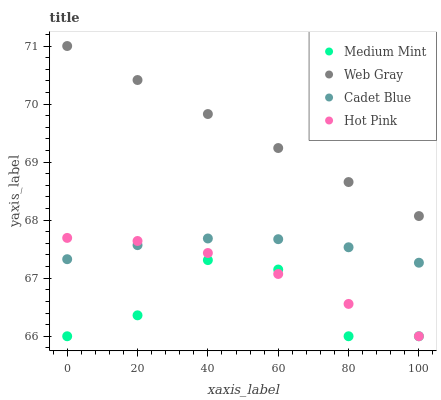Does Medium Mint have the minimum area under the curve?
Answer yes or no. Yes. Does Web Gray have the maximum area under the curve?
Answer yes or no. Yes. Does Cadet Blue have the minimum area under the curve?
Answer yes or no. No. Does Cadet Blue have the maximum area under the curve?
Answer yes or no. No. Is Web Gray the smoothest?
Answer yes or no. Yes. Is Medium Mint the roughest?
Answer yes or no. Yes. Is Cadet Blue the smoothest?
Answer yes or no. No. Is Cadet Blue the roughest?
Answer yes or no. No. Does Medium Mint have the lowest value?
Answer yes or no. Yes. Does Cadet Blue have the lowest value?
Answer yes or no. No. Does Web Gray have the highest value?
Answer yes or no. Yes. Does Cadet Blue have the highest value?
Answer yes or no. No. Is Medium Mint less than Cadet Blue?
Answer yes or no. Yes. Is Web Gray greater than Cadet Blue?
Answer yes or no. Yes. Does Medium Mint intersect Hot Pink?
Answer yes or no. Yes. Is Medium Mint less than Hot Pink?
Answer yes or no. No. Is Medium Mint greater than Hot Pink?
Answer yes or no. No. Does Medium Mint intersect Cadet Blue?
Answer yes or no. No. 